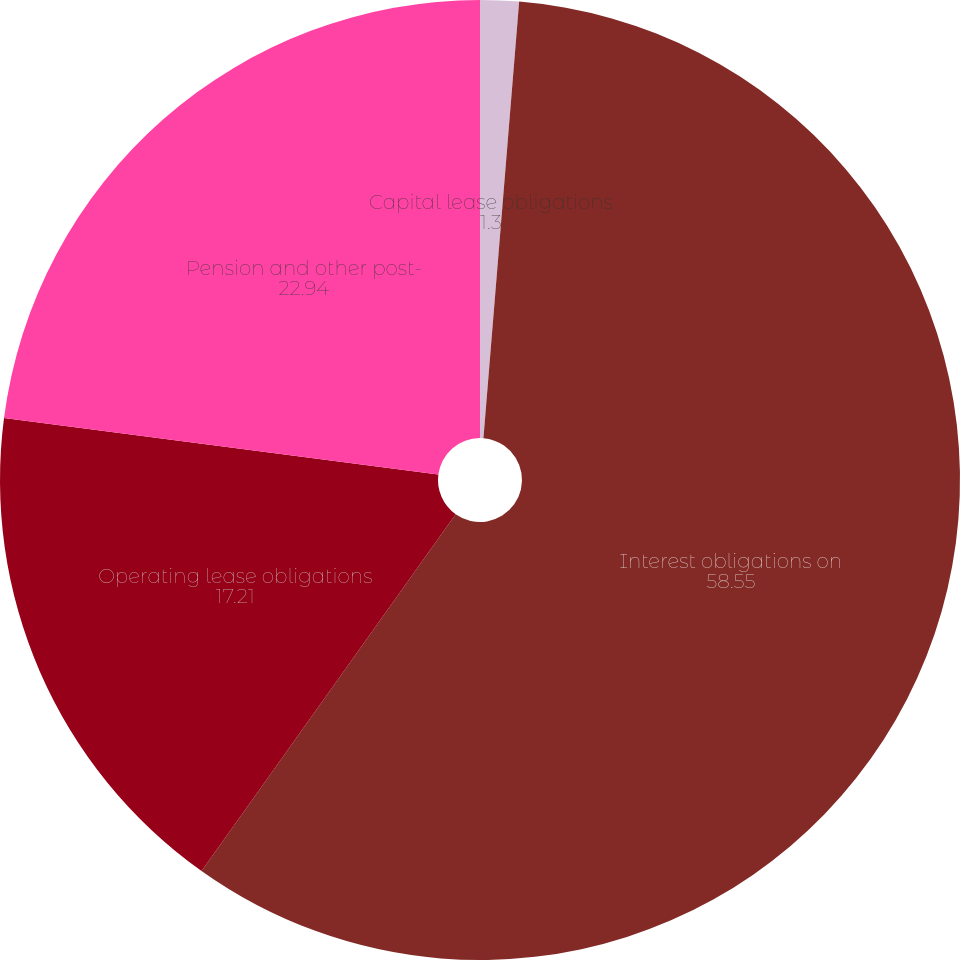Convert chart. <chart><loc_0><loc_0><loc_500><loc_500><pie_chart><fcel>Capital lease obligations<fcel>Interest obligations on<fcel>Operating lease obligations<fcel>Pension and other post-<nl><fcel>1.3%<fcel>58.55%<fcel>17.21%<fcel>22.94%<nl></chart> 